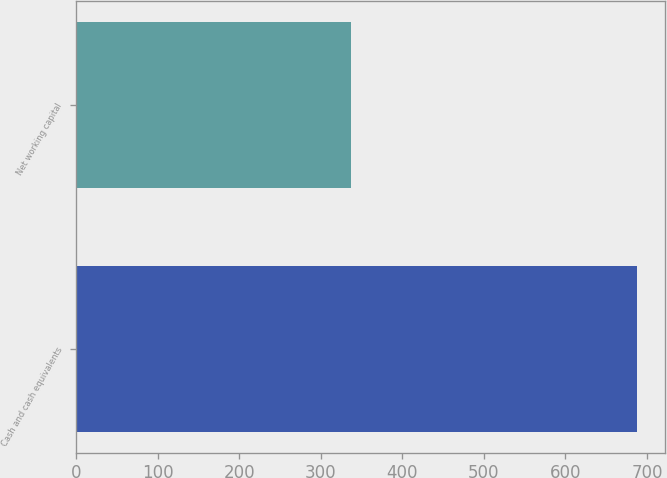<chart> <loc_0><loc_0><loc_500><loc_500><bar_chart><fcel>Cash and cash equivalents<fcel>Net working capital<nl><fcel>688.1<fcel>337.6<nl></chart> 